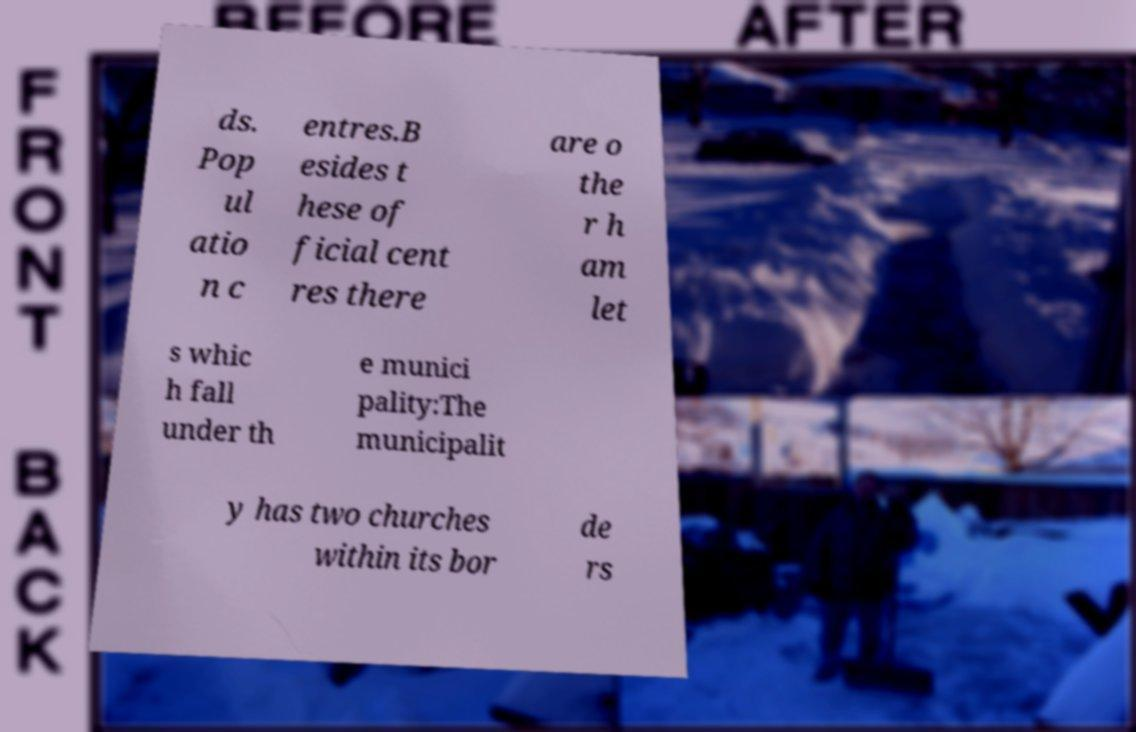Can you read and provide the text displayed in the image?This photo seems to have some interesting text. Can you extract and type it out for me? ds. Pop ul atio n c entres.B esides t hese of ficial cent res there are o the r h am let s whic h fall under th e munici pality:The municipalit y has two churches within its bor de rs 